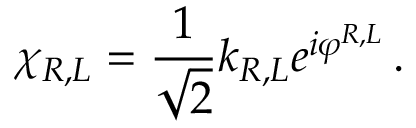Convert formula to latex. <formula><loc_0><loc_0><loc_500><loc_500>\chi _ { R , L } = \frac { 1 } { \sqrt { 2 } } k _ { R , L } e ^ { i \varphi ^ { R , L } } \, .</formula> 